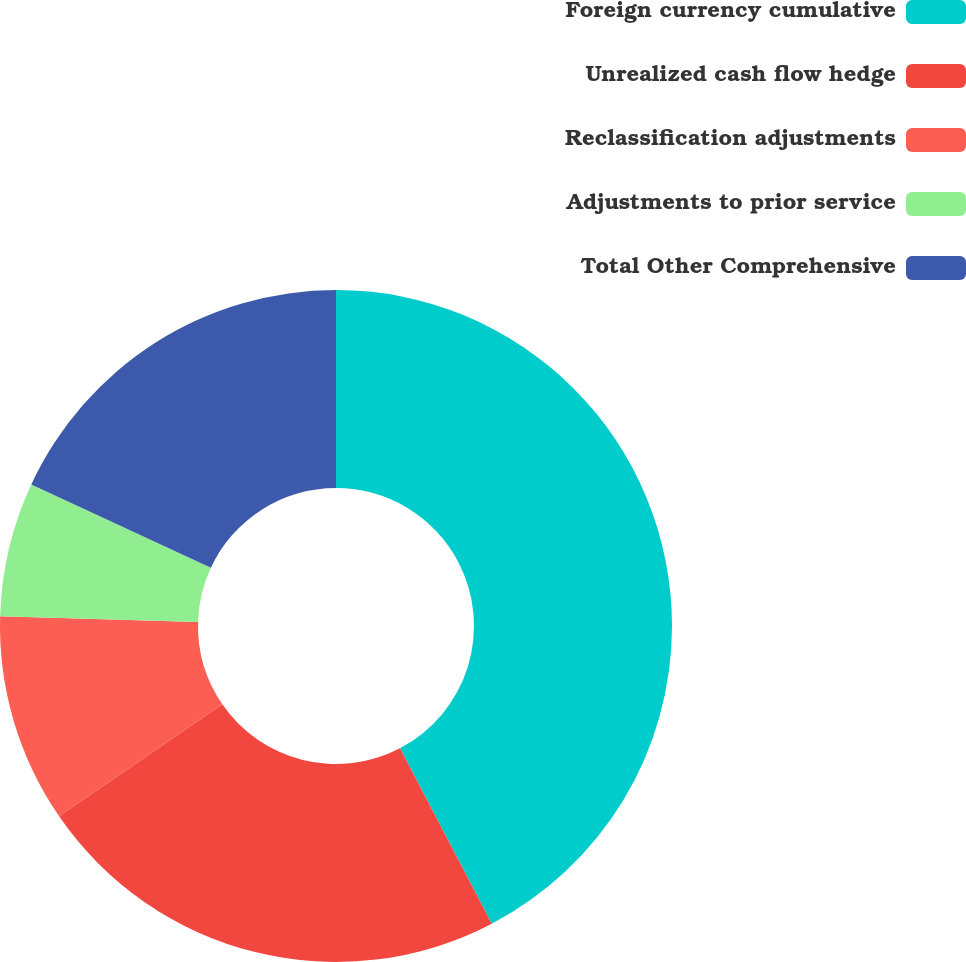<chart> <loc_0><loc_0><loc_500><loc_500><pie_chart><fcel>Foreign currency cumulative<fcel>Unrealized cash flow hedge<fcel>Reclassification adjustments<fcel>Adjustments to prior service<fcel>Total Other Comprehensive<nl><fcel>42.33%<fcel>23.09%<fcel>10.05%<fcel>6.46%<fcel>18.08%<nl></chart> 